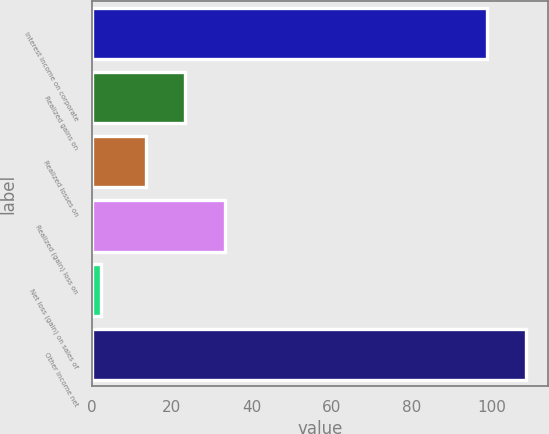Convert chart. <chart><loc_0><loc_0><loc_500><loc_500><bar_chart><fcel>Interest income on corporate<fcel>Realized gains on<fcel>Realized losses on<fcel>Realized (gain) loss on<fcel>Net loss (gain) on sales of<fcel>Other income net<nl><fcel>98.8<fcel>23.29<fcel>13.4<fcel>33.18<fcel>2.3<fcel>108.69<nl></chart> 